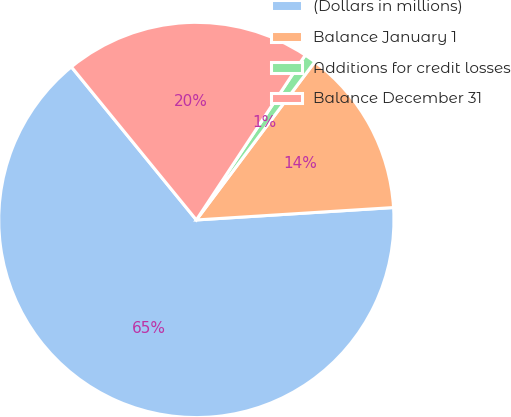Convert chart. <chart><loc_0><loc_0><loc_500><loc_500><pie_chart><fcel>(Dollars in millions)<fcel>Balance January 1<fcel>Additions for credit losses<fcel>Balance December 31<nl><fcel>65.11%<fcel>13.77%<fcel>0.94%<fcel>20.19%<nl></chart> 